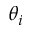Convert formula to latex. <formula><loc_0><loc_0><loc_500><loc_500>\theta _ { i }</formula> 